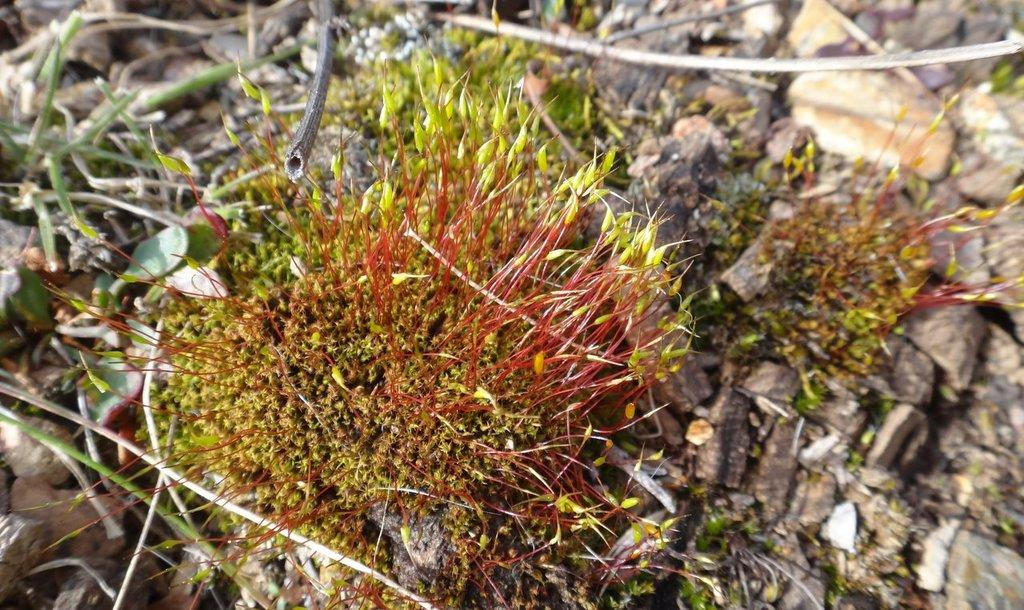What type of vegetation is present in the image? There is grass in the image. What else can be seen in the image besides the grass? There are stones in the image. What type of hat is the flower wearing in the image? There is no hat or flower present in the image. 